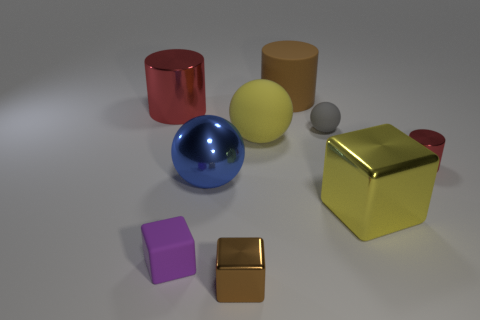Add 1 yellow balls. How many objects exist? 10 Subtract all shiny blocks. How many blocks are left? 1 Subtract all yellow balls. How many balls are left? 2 Subtract all balls. How many objects are left? 6 Add 2 shiny cylinders. How many shiny cylinders exist? 4 Subtract 0 red balls. How many objects are left? 9 Subtract 2 balls. How many balls are left? 1 Subtract all green cylinders. Subtract all blue balls. How many cylinders are left? 3 Subtract all brown cylinders. How many green spheres are left? 0 Subtract all brown metallic things. Subtract all gray matte balls. How many objects are left? 7 